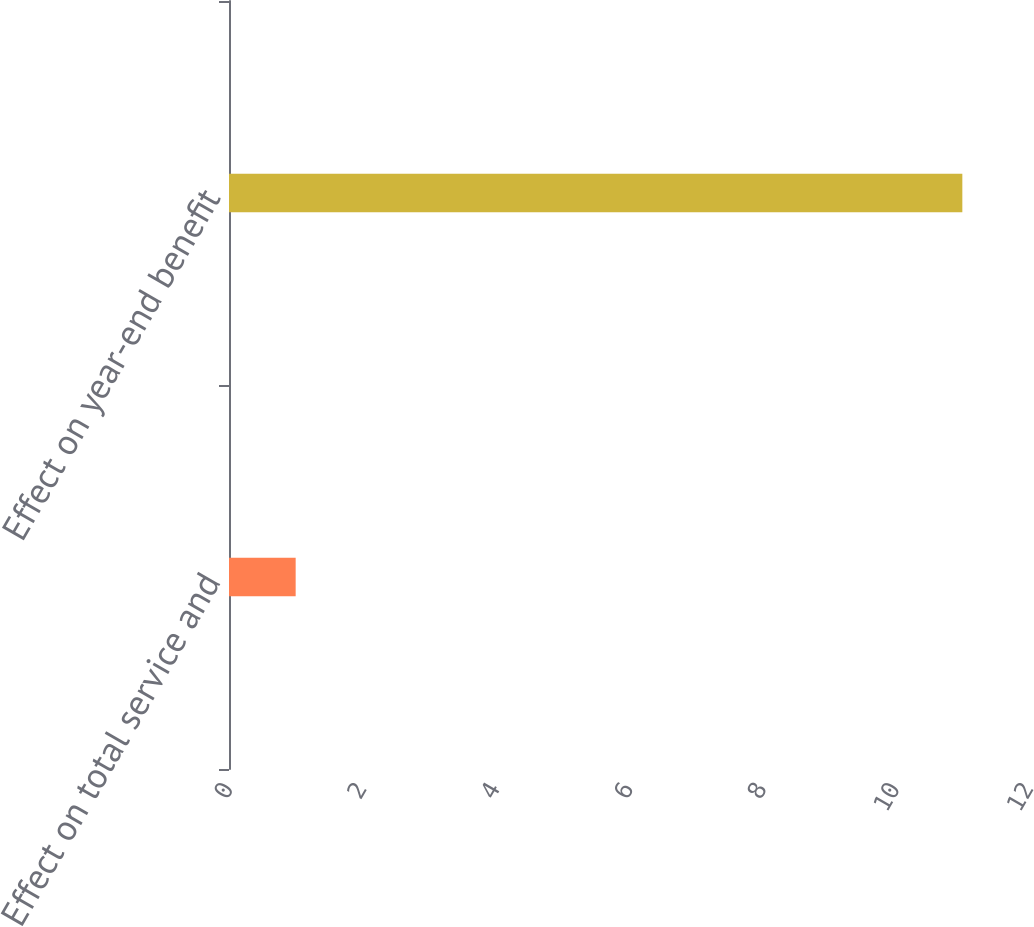Convert chart to OTSL. <chart><loc_0><loc_0><loc_500><loc_500><bar_chart><fcel>Effect on total service and<fcel>Effect on year-end benefit<nl><fcel>1<fcel>11<nl></chart> 